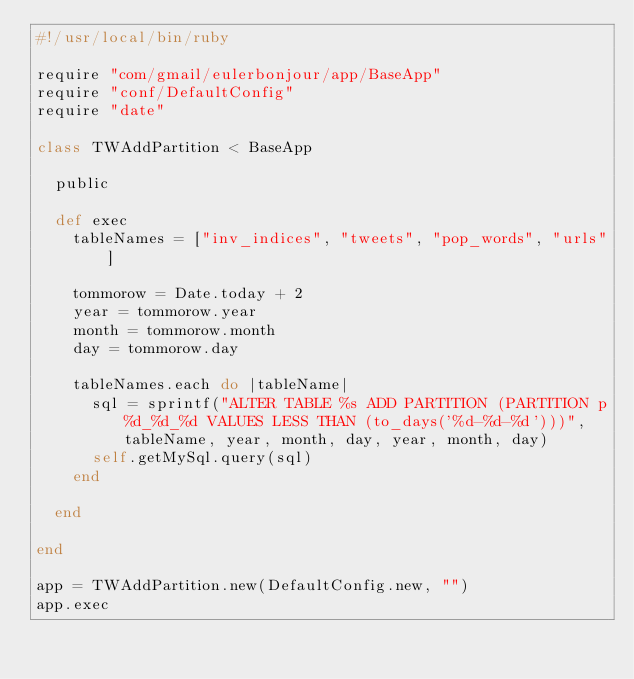Convert code to text. <code><loc_0><loc_0><loc_500><loc_500><_Ruby_>#!/usr/local/bin/ruby

require "com/gmail/eulerbonjour/app/BaseApp"
require "conf/DefaultConfig"
require "date"

class TWAddPartition < BaseApp

  public

  def exec
    tableNames = ["inv_indices", "tweets", "pop_words", "urls"]

    tommorow = Date.today + 2
    year = tommorow.year
    month = tommorow.month
    day = tommorow.day

    tableNames.each do |tableName|
      sql = sprintf("ALTER TABLE %s ADD PARTITION (PARTITION p%d_%d_%d VALUES LESS THAN (to_days('%d-%d-%d')))", tableName, year, month, day, year, month, day)
      self.getMySql.query(sql)
    end

  end

end

app = TWAddPartition.new(DefaultConfig.new, "")
app.exec
</code> 